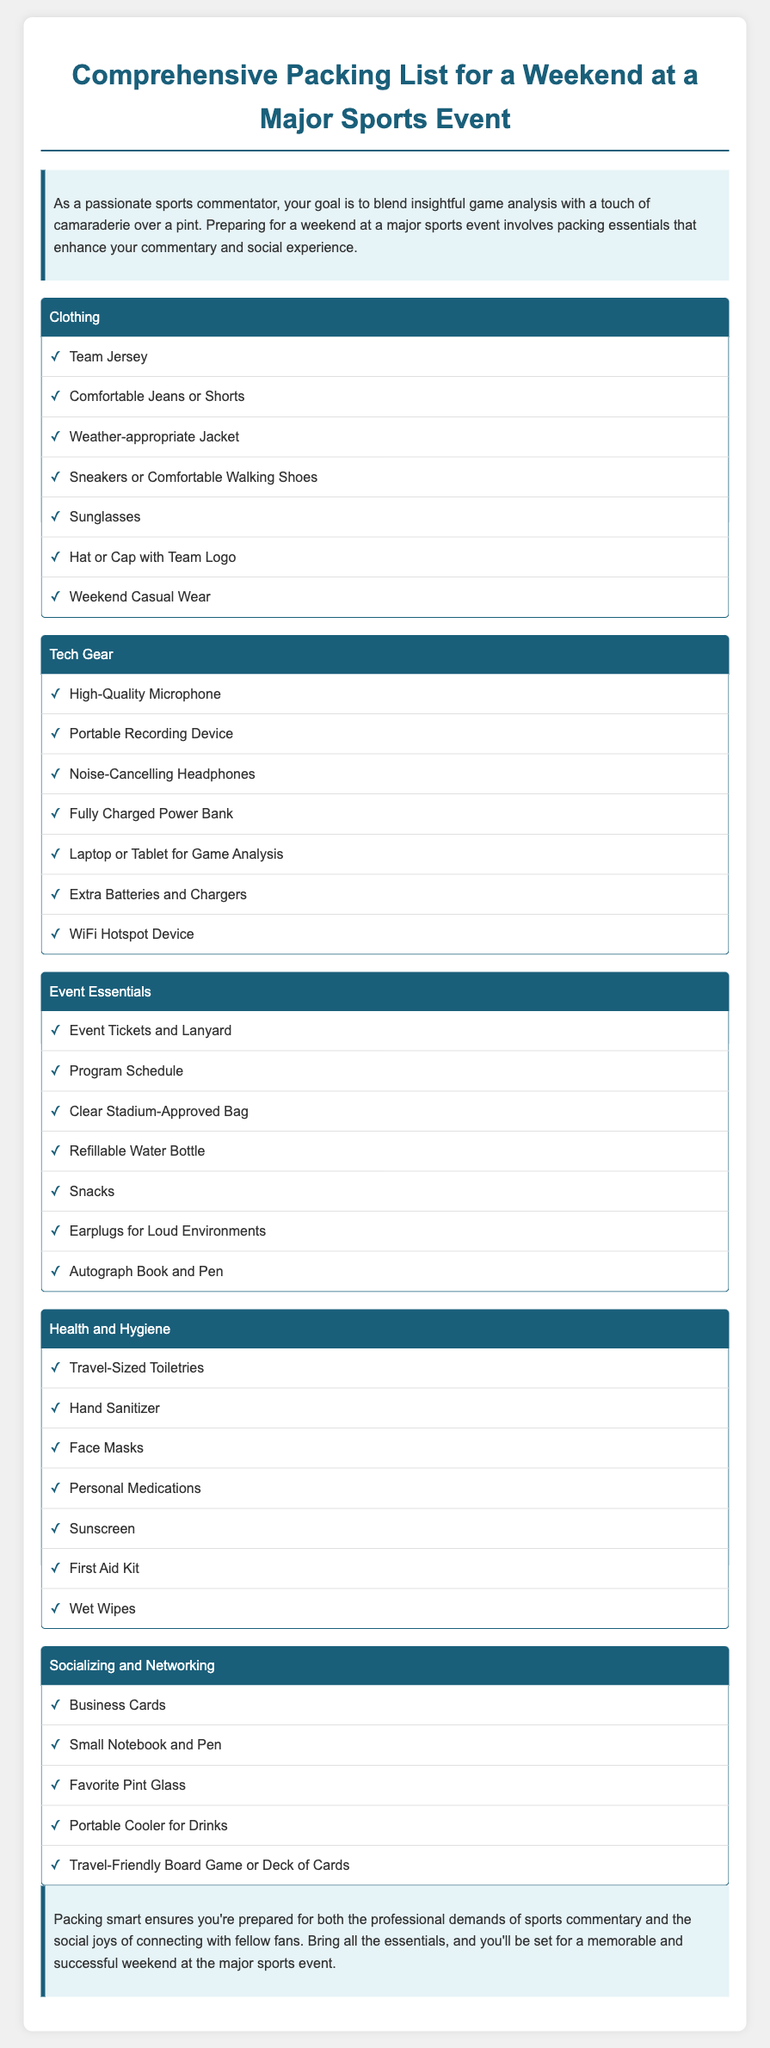what is included in the clothing category? The clothing category lists items such as Team Jersey, Comfortable Jeans or Shorts, Weather-appropriate Jacket, and others.
Answer: Team Jersey, Comfortable Jeans or Shorts, Weather-appropriate Jacket, Sneakers or Comfortable Walking Shoes, Sunglasses, Hat or Cap with Team Logo, Weekend Casual Wear how many items are listed under tech gear? The document lists seven items under the tech gear category.
Answer: 7 which item in the event essentials is used for hydration? The event essentials category mentions a refillable water bottle as a hydration item.
Answer: Refillable Water Bottle what is the purpose of bringing a portable cooler? The portable cooler is intended for carrying drinks to enjoy while socializing.
Answer: To carry drinks what hygiene item is mentioned for personal cleanliness? The document suggests bringing hand sanitizer for personal cleanliness.
Answer: Hand Sanitizer what type of item is recommended for networking? The document recommends bringing business cards for networking opportunities.
Answer: Business Cards how many categories are included in the packing list? There are five categories listed in the packing list.
Answer: 5 what is the first item in the health and hygiene category? The first item listed in the health and hygiene category is travel-sized toiletries.
Answer: Travel-Sized Toiletries what does the conclusion emphasize about preparation? The conclusion emphasizes that packing smart ensures you're prepared for the professional and social aspects of the event.
Answer: Packing smart ensures preparation for professional and social aspects 